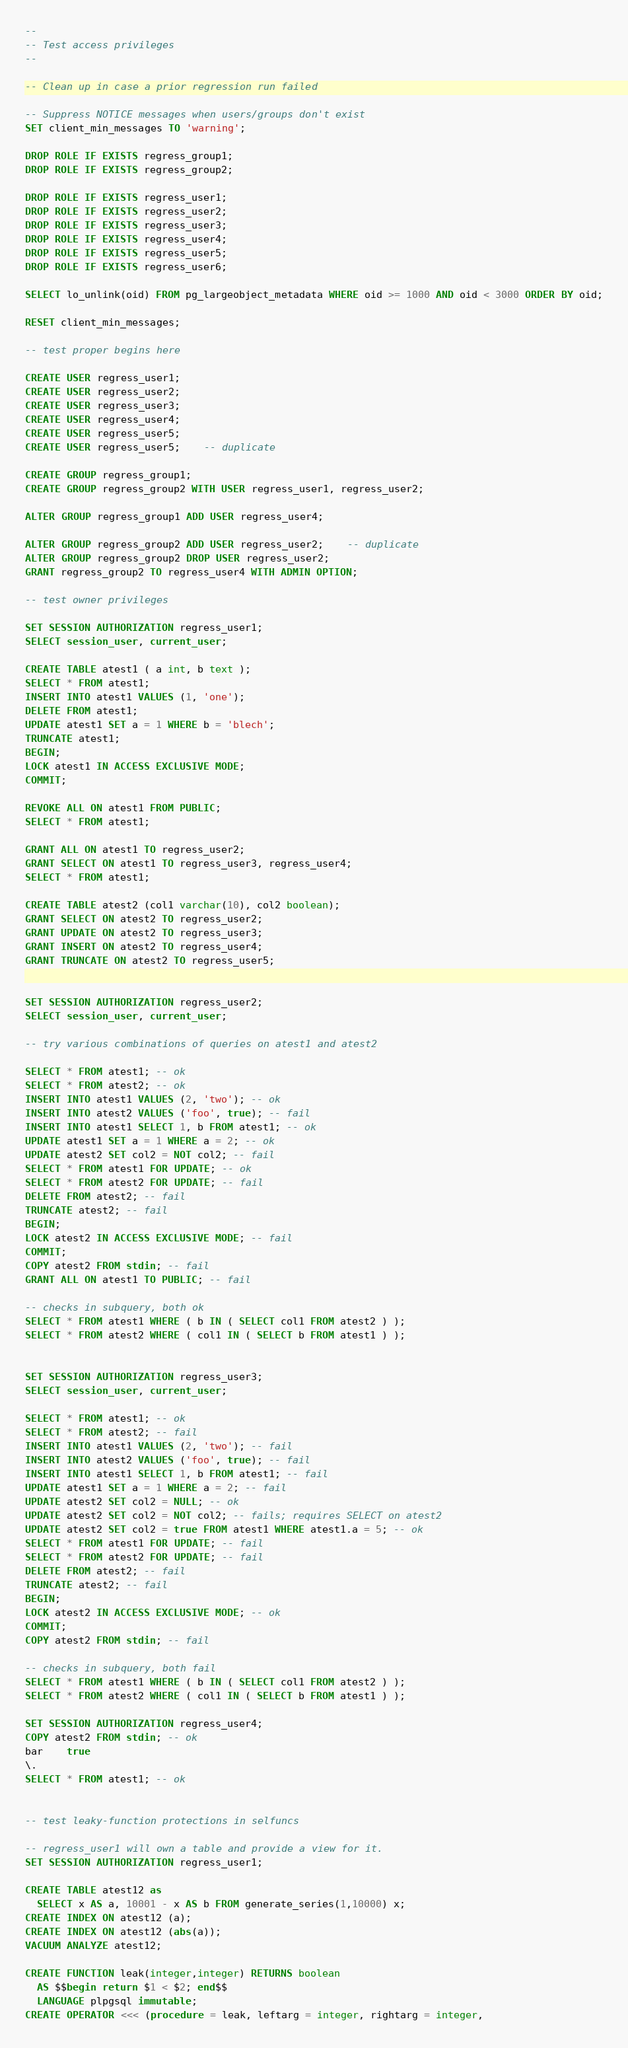<code> <loc_0><loc_0><loc_500><loc_500><_SQL_>--
-- Test access privileges
--

-- Clean up in case a prior regression run failed

-- Suppress NOTICE messages when users/groups don't exist
SET client_min_messages TO 'warning';

DROP ROLE IF EXISTS regress_group1;
DROP ROLE IF EXISTS regress_group2;

DROP ROLE IF EXISTS regress_user1;
DROP ROLE IF EXISTS regress_user2;
DROP ROLE IF EXISTS regress_user3;
DROP ROLE IF EXISTS regress_user4;
DROP ROLE IF EXISTS regress_user5;
DROP ROLE IF EXISTS regress_user6;

SELECT lo_unlink(oid) FROM pg_largeobject_metadata WHERE oid >= 1000 AND oid < 3000 ORDER BY oid;

RESET client_min_messages;

-- test proper begins here

CREATE USER regress_user1;
CREATE USER regress_user2;
CREATE USER regress_user3;
CREATE USER regress_user4;
CREATE USER regress_user5;
CREATE USER regress_user5;	-- duplicate

CREATE GROUP regress_group1;
CREATE GROUP regress_group2 WITH USER regress_user1, regress_user2;

ALTER GROUP regress_group1 ADD USER regress_user4;

ALTER GROUP regress_group2 ADD USER regress_user2;	-- duplicate
ALTER GROUP regress_group2 DROP USER regress_user2;
GRANT regress_group2 TO regress_user4 WITH ADMIN OPTION;

-- test owner privileges

SET SESSION AUTHORIZATION regress_user1;
SELECT session_user, current_user;

CREATE TABLE atest1 ( a int, b text );
SELECT * FROM atest1;
INSERT INTO atest1 VALUES (1, 'one');
DELETE FROM atest1;
UPDATE atest1 SET a = 1 WHERE b = 'blech';
TRUNCATE atest1;
BEGIN;
LOCK atest1 IN ACCESS EXCLUSIVE MODE;
COMMIT;

REVOKE ALL ON atest1 FROM PUBLIC;
SELECT * FROM atest1;

GRANT ALL ON atest1 TO regress_user2;
GRANT SELECT ON atest1 TO regress_user3, regress_user4;
SELECT * FROM atest1;

CREATE TABLE atest2 (col1 varchar(10), col2 boolean);
GRANT SELECT ON atest2 TO regress_user2;
GRANT UPDATE ON atest2 TO regress_user3;
GRANT INSERT ON atest2 TO regress_user4;
GRANT TRUNCATE ON atest2 TO regress_user5;


SET SESSION AUTHORIZATION regress_user2;
SELECT session_user, current_user;

-- try various combinations of queries on atest1 and atest2

SELECT * FROM atest1; -- ok
SELECT * FROM atest2; -- ok
INSERT INTO atest1 VALUES (2, 'two'); -- ok
INSERT INTO atest2 VALUES ('foo', true); -- fail
INSERT INTO atest1 SELECT 1, b FROM atest1; -- ok
UPDATE atest1 SET a = 1 WHERE a = 2; -- ok
UPDATE atest2 SET col2 = NOT col2; -- fail
SELECT * FROM atest1 FOR UPDATE; -- ok
SELECT * FROM atest2 FOR UPDATE; -- fail
DELETE FROM atest2; -- fail
TRUNCATE atest2; -- fail
BEGIN;
LOCK atest2 IN ACCESS EXCLUSIVE MODE; -- fail
COMMIT;
COPY atest2 FROM stdin; -- fail
GRANT ALL ON atest1 TO PUBLIC; -- fail

-- checks in subquery, both ok
SELECT * FROM atest1 WHERE ( b IN ( SELECT col1 FROM atest2 ) );
SELECT * FROM atest2 WHERE ( col1 IN ( SELECT b FROM atest1 ) );


SET SESSION AUTHORIZATION regress_user3;
SELECT session_user, current_user;

SELECT * FROM atest1; -- ok
SELECT * FROM atest2; -- fail
INSERT INTO atest1 VALUES (2, 'two'); -- fail
INSERT INTO atest2 VALUES ('foo', true); -- fail
INSERT INTO atest1 SELECT 1, b FROM atest1; -- fail
UPDATE atest1 SET a = 1 WHERE a = 2; -- fail
UPDATE atest2 SET col2 = NULL; -- ok
UPDATE atest2 SET col2 = NOT col2; -- fails; requires SELECT on atest2
UPDATE atest2 SET col2 = true FROM atest1 WHERE atest1.a = 5; -- ok
SELECT * FROM atest1 FOR UPDATE; -- fail
SELECT * FROM atest2 FOR UPDATE; -- fail
DELETE FROM atest2; -- fail
TRUNCATE atest2; -- fail
BEGIN;
LOCK atest2 IN ACCESS EXCLUSIVE MODE; -- ok
COMMIT;
COPY atest2 FROM stdin; -- fail

-- checks in subquery, both fail
SELECT * FROM atest1 WHERE ( b IN ( SELECT col1 FROM atest2 ) );
SELECT * FROM atest2 WHERE ( col1 IN ( SELECT b FROM atest1 ) );

SET SESSION AUTHORIZATION regress_user4;
COPY atest2 FROM stdin; -- ok
bar	true
\.
SELECT * FROM atest1; -- ok


-- test leaky-function protections in selfuncs

-- regress_user1 will own a table and provide a view for it.
SET SESSION AUTHORIZATION regress_user1;

CREATE TABLE atest12 as
  SELECT x AS a, 10001 - x AS b FROM generate_series(1,10000) x;
CREATE INDEX ON atest12 (a);
CREATE INDEX ON atest12 (abs(a));
VACUUM ANALYZE atest12;

CREATE FUNCTION leak(integer,integer) RETURNS boolean
  AS $$begin return $1 < $2; end$$
  LANGUAGE plpgsql immutable;
CREATE OPERATOR <<< (procedure = leak, leftarg = integer, rightarg = integer,</code> 